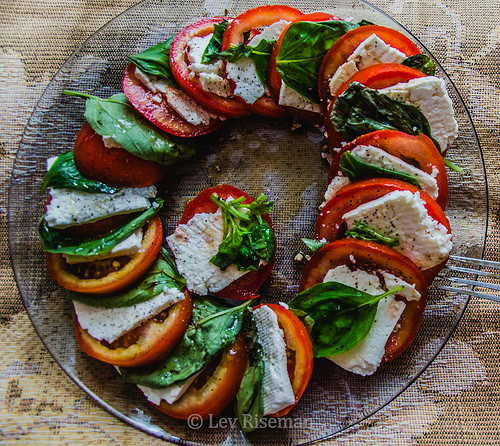<image>
Can you confirm if the tomato is above the plate? No. The tomato is not positioned above the plate. The vertical arrangement shows a different relationship. 